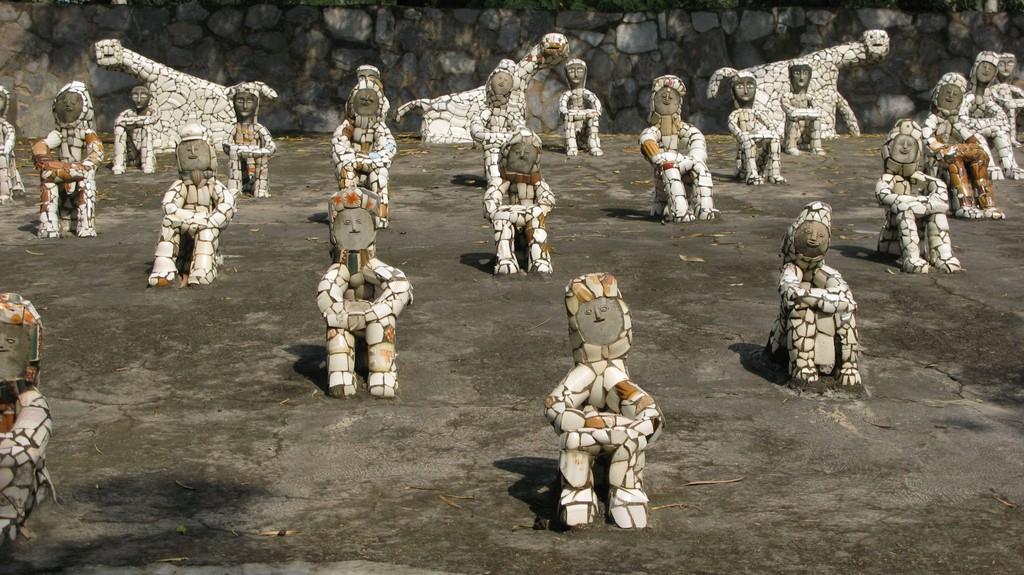How would you summarize this image in a sentence or two? In this picture we can see statues on the surface. In the background of the image we can see stone wall. 